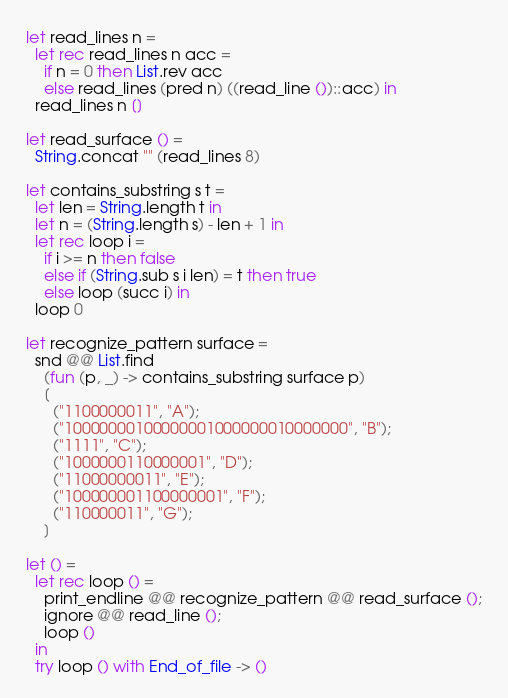<code> <loc_0><loc_0><loc_500><loc_500><_OCaml_>let read_lines n =
  let rec read_lines n acc =
    if n = 0 then List.rev acc
    else read_lines (pred n) ((read_line ())::acc) in
  read_lines n []

let read_surface () =
  String.concat "" (read_lines 8)

let contains_substring s t =
  let len = String.length t in
  let n = (String.length s) - len + 1 in
  let rec loop i =
    if i >= n then false
    else if (String.sub s i len) = t then true
    else loop (succ i) in
  loop 0

let recognize_pattern surface =
  snd @@ List.find
    (fun (p, _) -> contains_substring surface p)
    [
      ("1100000011", "A");
      ("10000000100000001000000010000000", "B");
      ("1111", "C");
      ("1000000110000001", "D");
      ("11000000011", "E");
      ("100000001100000001", "F");
      ("110000011", "G");
    ]

let () =
  let rec loop () =
    print_endline @@ recognize_pattern @@ read_surface ();
    ignore @@ read_line ();
    loop ()
  in
  try loop () with End_of_file -> ()</code> 